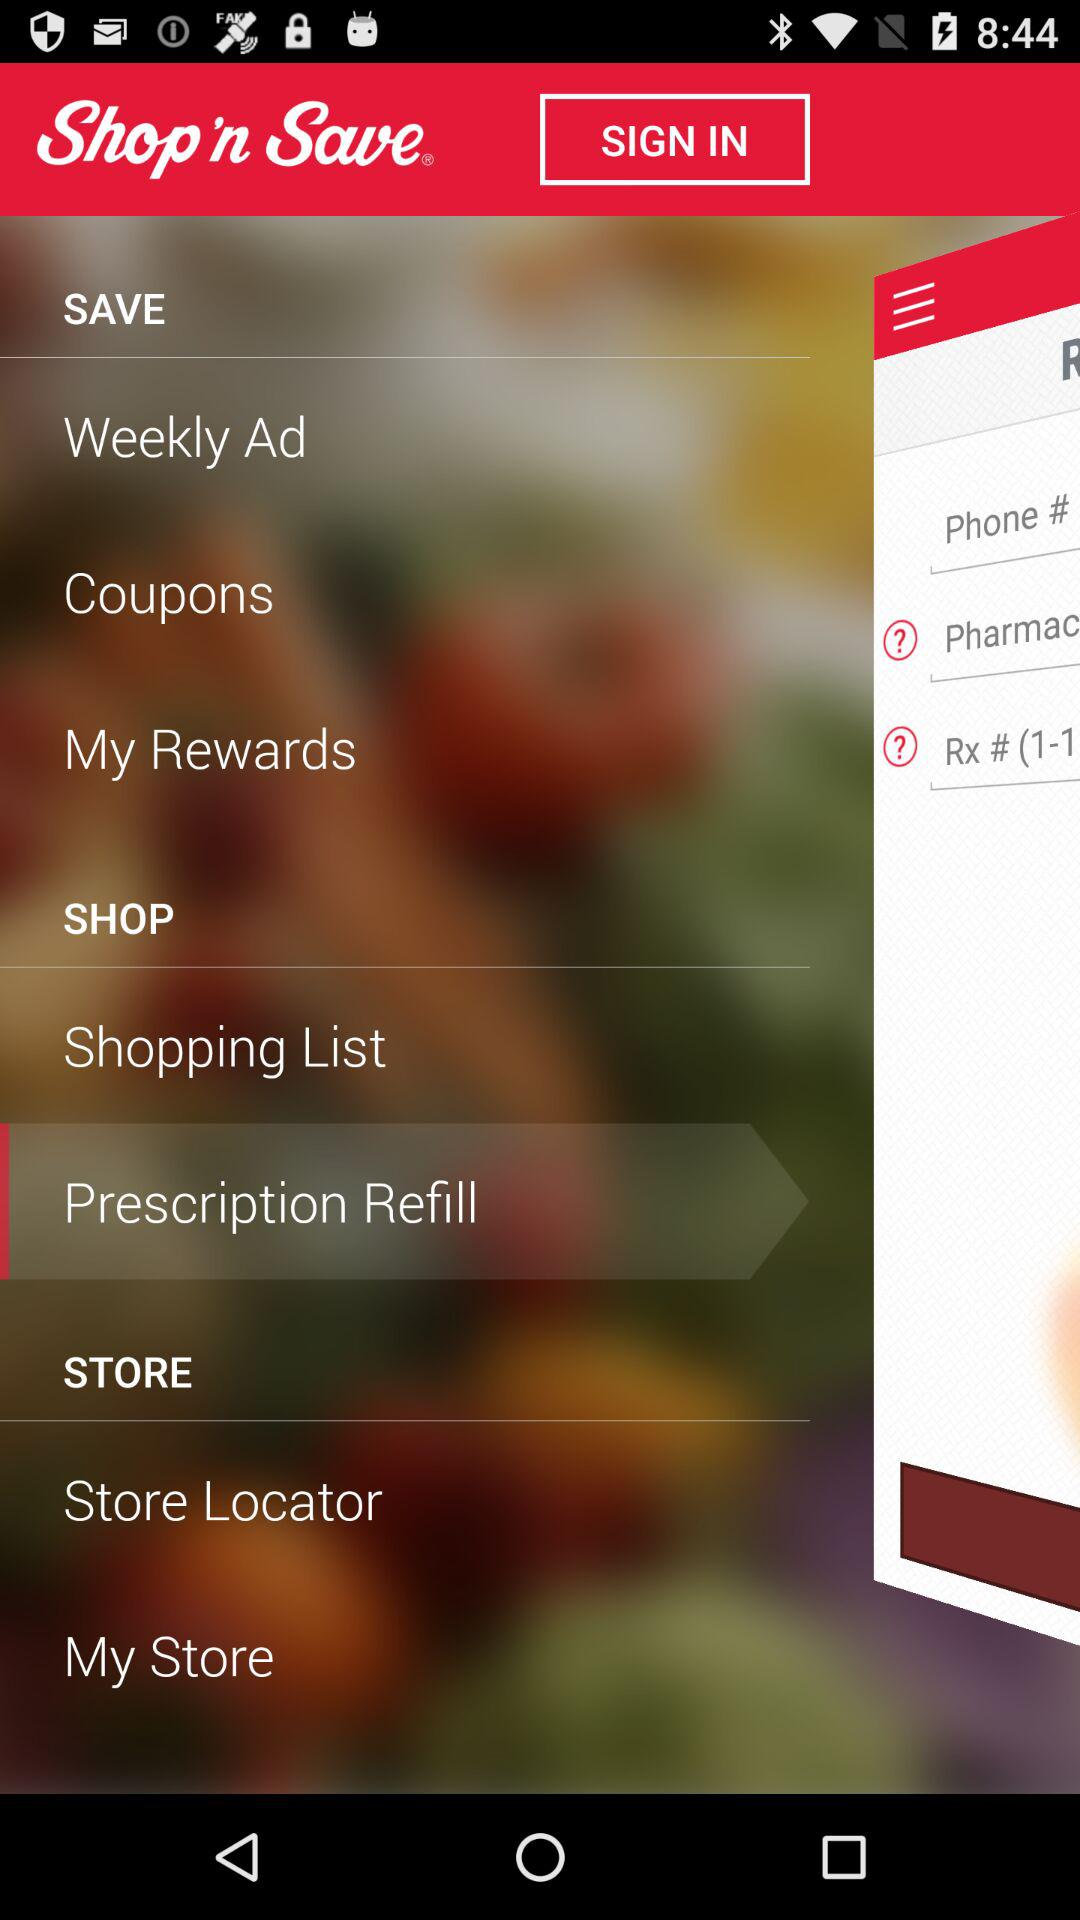What is the name of the application? The name of the application is "Shop 'n Save". 